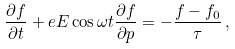<formula> <loc_0><loc_0><loc_500><loc_500>\frac { \partial f } { \partial t } + e E \cos { \omega t } \frac { \partial f } { \partial p } = - \frac { f - f _ { 0 } } { \tau } \, ,</formula> 